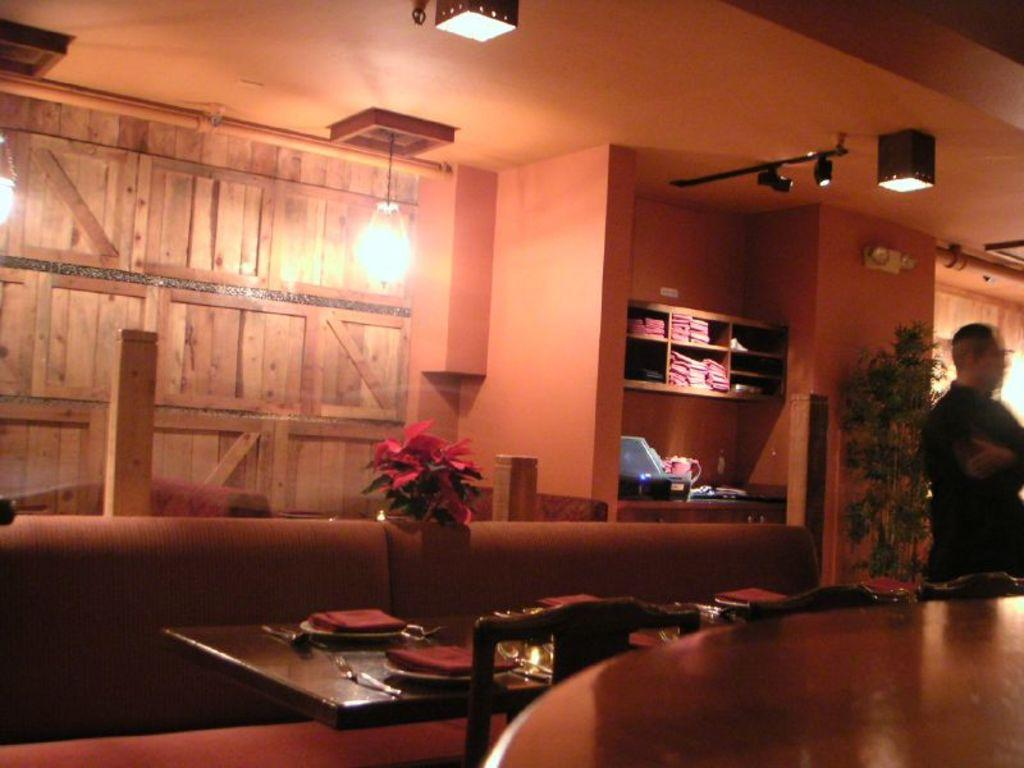What objects are on the table in the image? There are plates, spoons, and glasses on the table in the image. What furniture is located beside the table? There are chairs beside the table. What type of lighting is present in the image? There are lights in the image. What is used for storage in the image? There are racks in the image. What decorative item can be seen on the table? There is a flower vase in the image. What type of screen is visible in the image? There is a screen in the image. Where is the person standing in relation to the plant? The person is standing in front of a plant. On which side of the image is the plant located? The plant is on the right side of the image. What type of head can be seen on the table in the image? There is no head present on the table in the image. 